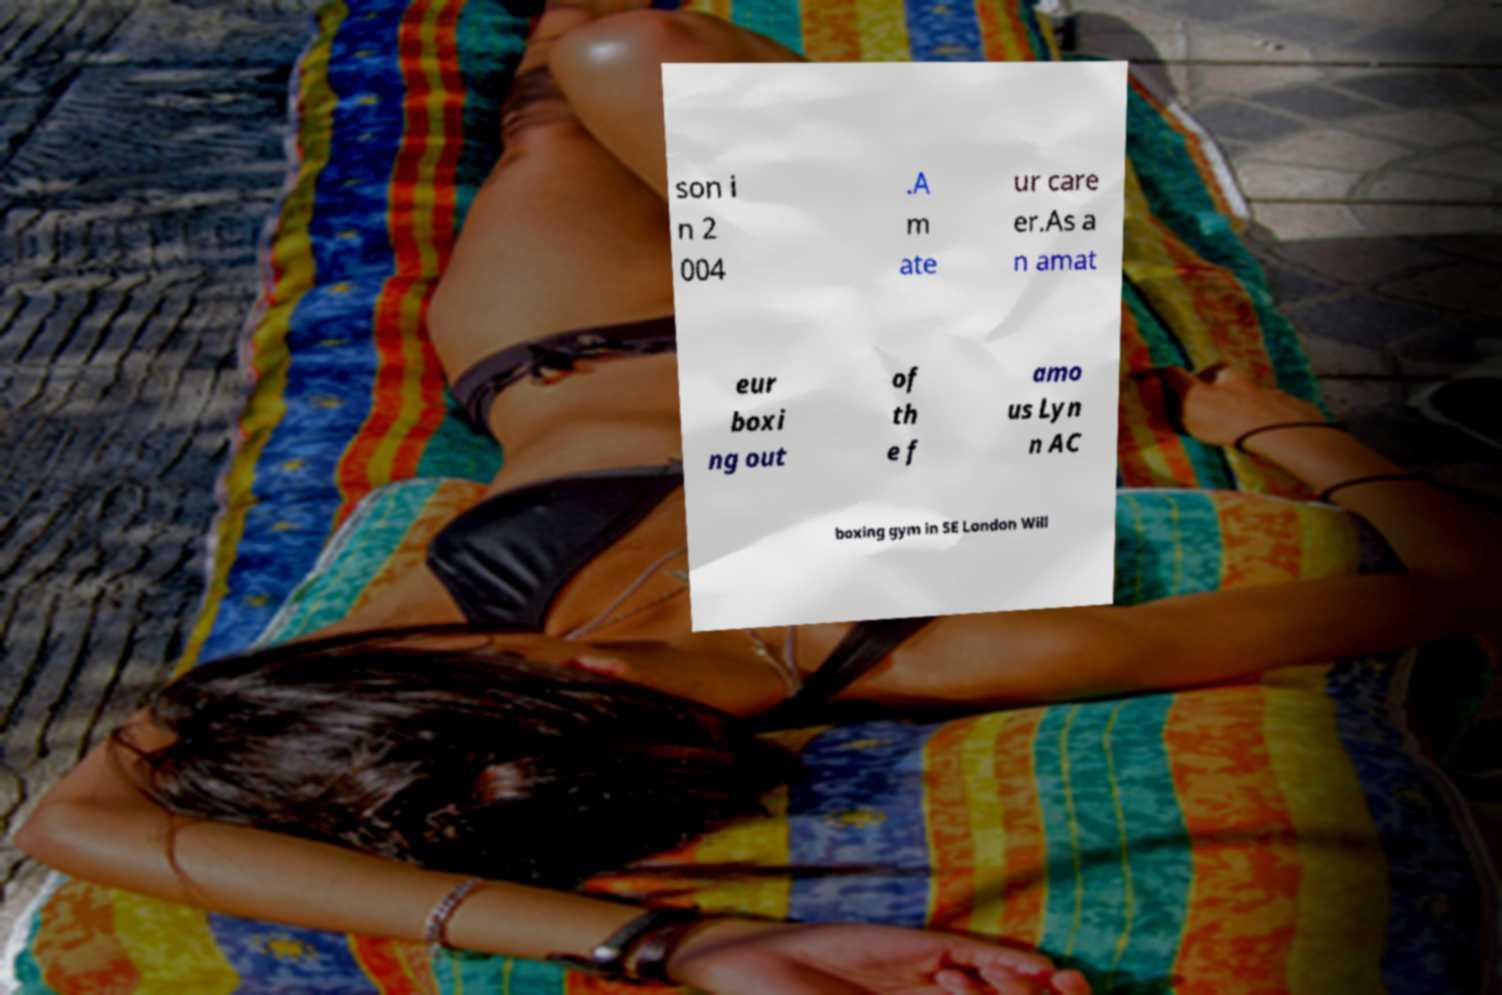Please identify and transcribe the text found in this image. son i n 2 004 .A m ate ur care er.As a n amat eur boxi ng out of th e f amo us Lyn n AC boxing gym in SE London Will 